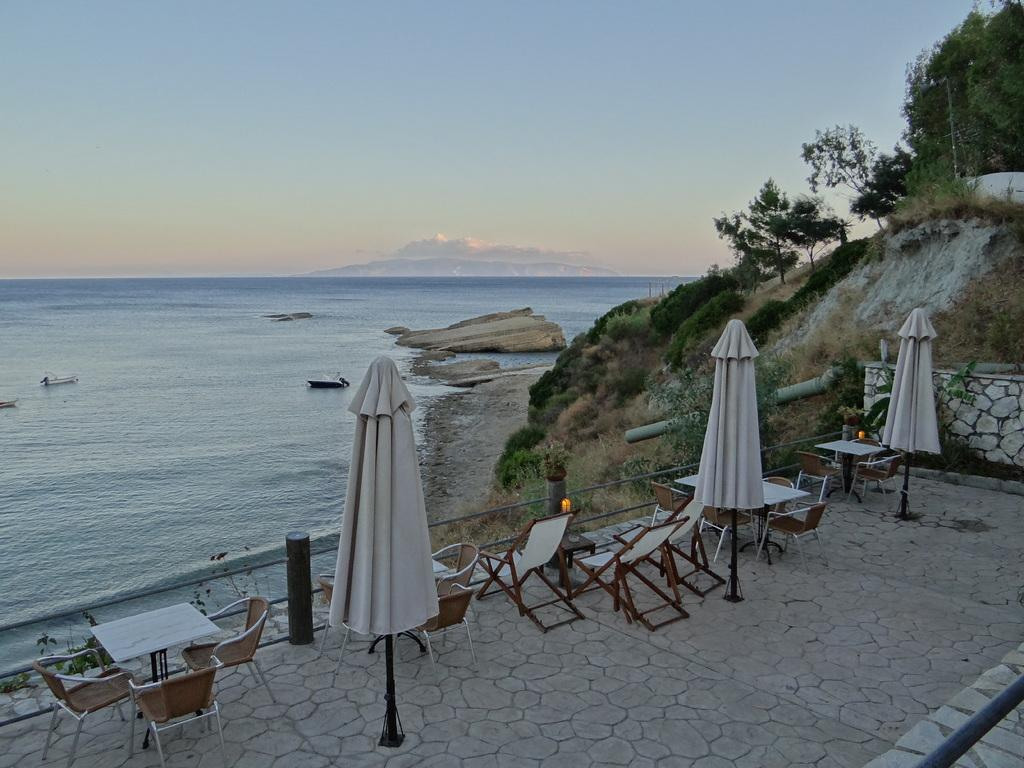What type of furniture is visible in the image? There are tables and chairs in the image. What natural landscape can be seen in the image? There is a hill with trees in the image. What body of water is present? There is an ocean in the image. What is visible in the upper part of the image? The sky is visible in the image. What can be observed in the sky? Clouds are present in the sky. How many beds are visible in the image? There are no beds present in the image. Is there a squirrel visible on the hill in the image? There is no squirrel visible in the image. 